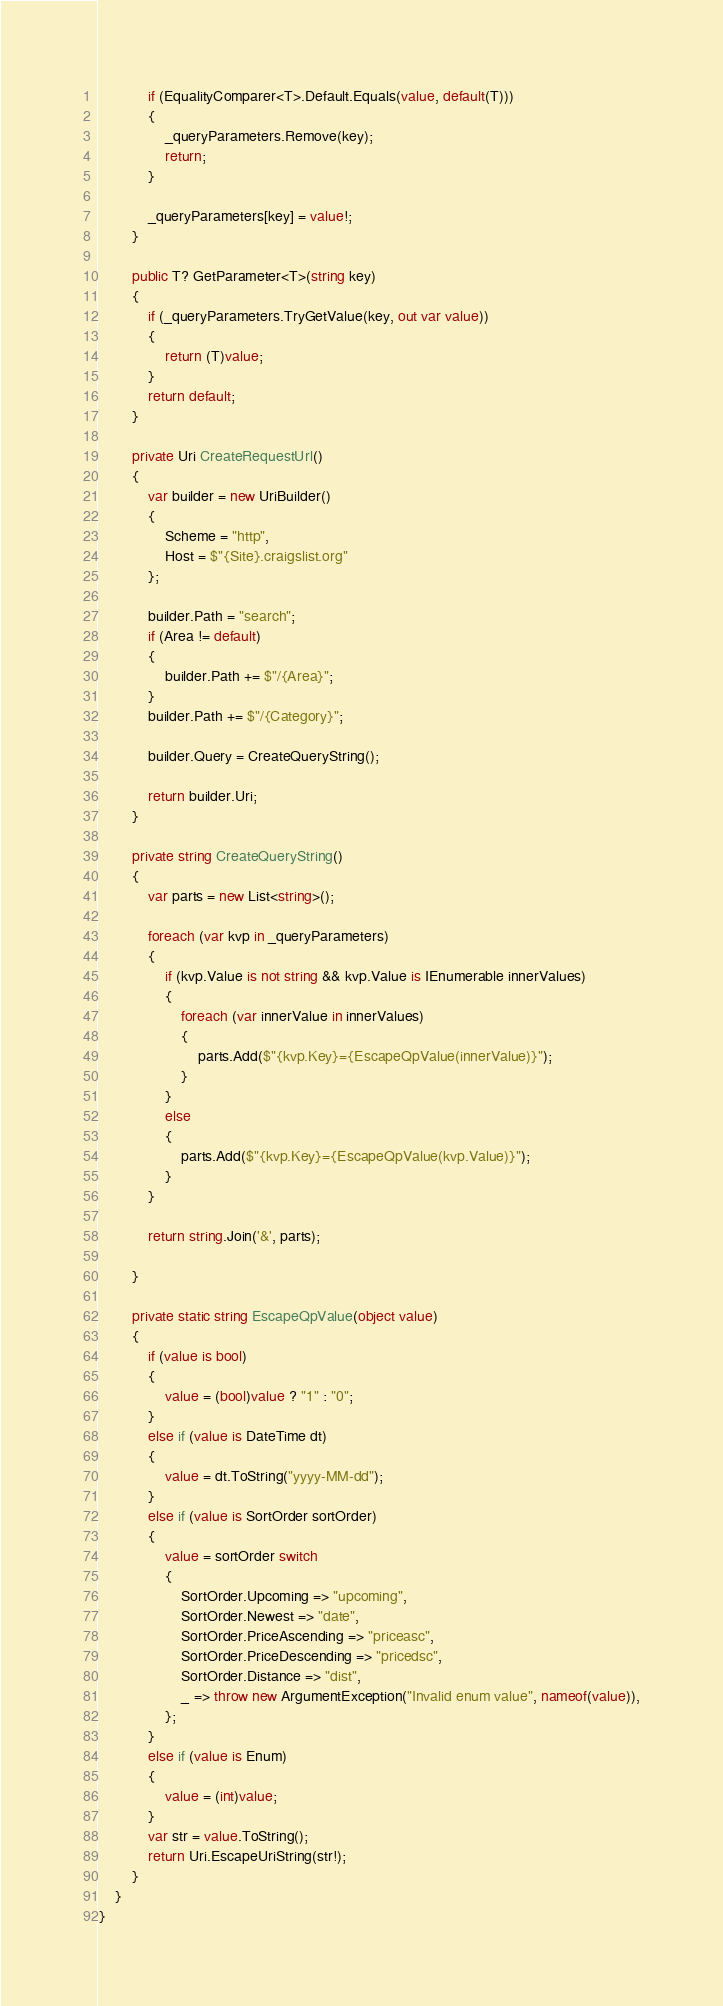Convert code to text. <code><loc_0><loc_0><loc_500><loc_500><_C#_>            if (EqualityComparer<T>.Default.Equals(value, default(T)))
            {
                _queryParameters.Remove(key);
                return;
            }
            
            _queryParameters[key] = value!;
        }

        public T? GetParameter<T>(string key)
        {
            if (_queryParameters.TryGetValue(key, out var value))
            {
                return (T)value;
            }
            return default;
        }

        private Uri CreateRequestUrl()
        {
            var builder = new UriBuilder()
            {
                Scheme = "http",
                Host = $"{Site}.craigslist.org"
            };

            builder.Path = "search";
            if (Area != default)
            {
                builder.Path += $"/{Area}";
            }
            builder.Path += $"/{Category}";

            builder.Query = CreateQueryString();

            return builder.Uri;
        }

        private string CreateQueryString()
        {
            var parts = new List<string>();

            foreach (var kvp in _queryParameters)
            {
                if (kvp.Value is not string && kvp.Value is IEnumerable innerValues)
                {
                    foreach (var innerValue in innerValues)
                    {
                        parts.Add($"{kvp.Key}={EscapeQpValue(innerValue)}");
                    }
                }
                else
                {
                    parts.Add($"{kvp.Key}={EscapeQpValue(kvp.Value)}");
                }
            }

            return string.Join('&', parts);

        }

        private static string EscapeQpValue(object value)
        {
            if (value is bool)
            {
                value = (bool)value ? "1" : "0";
            }
            else if (value is DateTime dt)
            {
                value = dt.ToString("yyyy-MM-dd");
            }
            else if (value is SortOrder sortOrder)
            {
                value = sortOrder switch
                {
                    SortOrder.Upcoming => "upcoming",
                    SortOrder.Newest => "date",
                    SortOrder.PriceAscending => "priceasc",
                    SortOrder.PriceDescending => "pricedsc",
                    SortOrder.Distance => "dist",
                    _ => throw new ArgumentException("Invalid enum value", nameof(value)),
                };
            }
            else if (value is Enum)
            {
                value = (int)value;
            }
            var str = value.ToString();
            return Uri.EscapeUriString(str!);
        }
    }
}</code> 